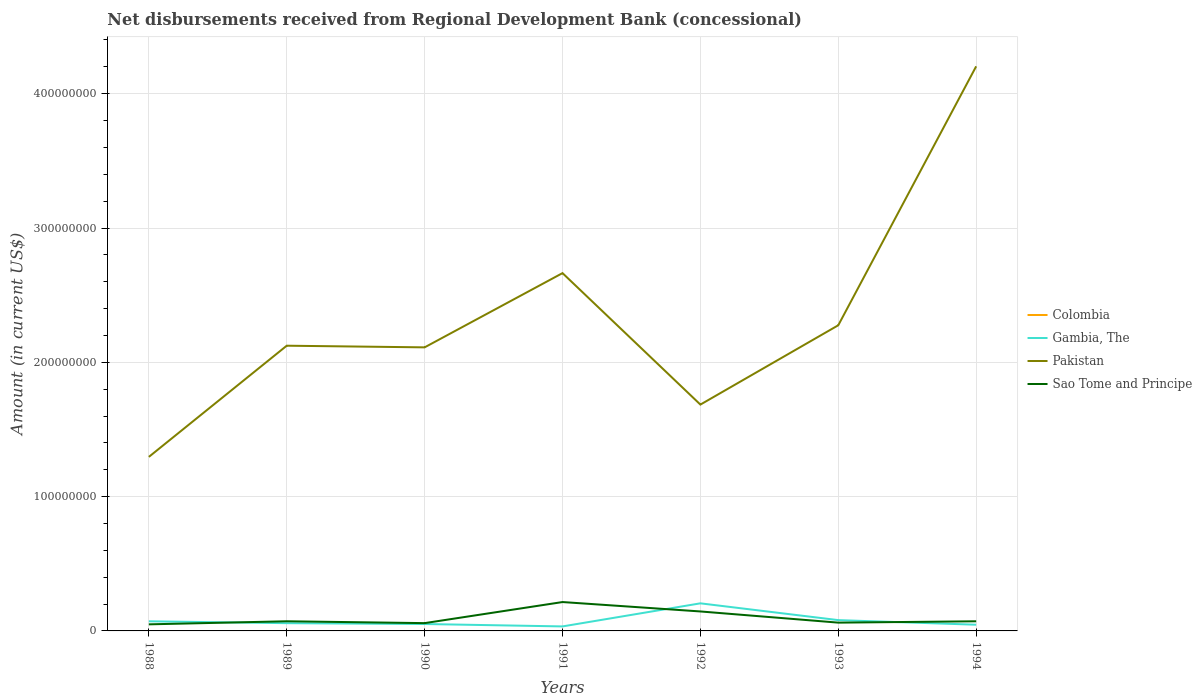How many different coloured lines are there?
Ensure brevity in your answer.  3. Across all years, what is the maximum amount of disbursements received from Regional Development Bank in Pakistan?
Provide a short and direct response. 1.30e+08. What is the total amount of disbursements received from Regional Development Bank in Sao Tome and Principe in the graph?
Keep it short and to the point. 8.32e+06. What is the difference between the highest and the second highest amount of disbursements received from Regional Development Bank in Gambia, The?
Provide a short and direct response. 1.72e+07. Does the graph contain any zero values?
Provide a succinct answer. Yes. Does the graph contain grids?
Make the answer very short. Yes. How many legend labels are there?
Provide a short and direct response. 4. What is the title of the graph?
Offer a very short reply. Net disbursements received from Regional Development Bank (concessional). Does "Argentina" appear as one of the legend labels in the graph?
Keep it short and to the point. No. What is the label or title of the Y-axis?
Your response must be concise. Amount (in current US$). What is the Amount (in current US$) in Gambia, The in 1988?
Make the answer very short. 7.16e+06. What is the Amount (in current US$) of Pakistan in 1988?
Keep it short and to the point. 1.30e+08. What is the Amount (in current US$) in Sao Tome and Principe in 1988?
Your response must be concise. 4.90e+06. What is the Amount (in current US$) of Gambia, The in 1989?
Make the answer very short. 5.77e+06. What is the Amount (in current US$) of Pakistan in 1989?
Offer a very short reply. 2.12e+08. What is the Amount (in current US$) of Sao Tome and Principe in 1989?
Ensure brevity in your answer.  7.19e+06. What is the Amount (in current US$) of Gambia, The in 1990?
Ensure brevity in your answer.  5.14e+06. What is the Amount (in current US$) in Pakistan in 1990?
Provide a short and direct response. 2.11e+08. What is the Amount (in current US$) in Sao Tome and Principe in 1990?
Offer a very short reply. 5.80e+06. What is the Amount (in current US$) of Colombia in 1991?
Give a very brief answer. 0. What is the Amount (in current US$) of Gambia, The in 1991?
Provide a short and direct response. 3.35e+06. What is the Amount (in current US$) in Pakistan in 1991?
Keep it short and to the point. 2.66e+08. What is the Amount (in current US$) of Sao Tome and Principe in 1991?
Give a very brief answer. 2.15e+07. What is the Amount (in current US$) of Colombia in 1992?
Your answer should be very brief. 0. What is the Amount (in current US$) of Gambia, The in 1992?
Provide a succinct answer. 2.05e+07. What is the Amount (in current US$) in Pakistan in 1992?
Provide a succinct answer. 1.69e+08. What is the Amount (in current US$) in Sao Tome and Principe in 1992?
Ensure brevity in your answer.  1.45e+07. What is the Amount (in current US$) in Colombia in 1993?
Make the answer very short. 0. What is the Amount (in current US$) in Gambia, The in 1993?
Your answer should be compact. 8.04e+06. What is the Amount (in current US$) in Pakistan in 1993?
Give a very brief answer. 2.28e+08. What is the Amount (in current US$) in Sao Tome and Principe in 1993?
Keep it short and to the point. 6.17e+06. What is the Amount (in current US$) in Colombia in 1994?
Give a very brief answer. 0. What is the Amount (in current US$) of Gambia, The in 1994?
Offer a terse response. 4.61e+06. What is the Amount (in current US$) in Pakistan in 1994?
Offer a terse response. 4.20e+08. What is the Amount (in current US$) in Sao Tome and Principe in 1994?
Give a very brief answer. 7.17e+06. Across all years, what is the maximum Amount (in current US$) of Gambia, The?
Your answer should be compact. 2.05e+07. Across all years, what is the maximum Amount (in current US$) in Pakistan?
Your answer should be very brief. 4.20e+08. Across all years, what is the maximum Amount (in current US$) of Sao Tome and Principe?
Make the answer very short. 2.15e+07. Across all years, what is the minimum Amount (in current US$) in Gambia, The?
Offer a terse response. 3.35e+06. Across all years, what is the minimum Amount (in current US$) in Pakistan?
Your answer should be very brief. 1.30e+08. Across all years, what is the minimum Amount (in current US$) in Sao Tome and Principe?
Offer a terse response. 4.90e+06. What is the total Amount (in current US$) of Colombia in the graph?
Keep it short and to the point. 0. What is the total Amount (in current US$) in Gambia, The in the graph?
Your answer should be very brief. 5.46e+07. What is the total Amount (in current US$) of Pakistan in the graph?
Your answer should be compact. 1.64e+09. What is the total Amount (in current US$) in Sao Tome and Principe in the graph?
Give a very brief answer. 6.72e+07. What is the difference between the Amount (in current US$) in Gambia, The in 1988 and that in 1989?
Ensure brevity in your answer.  1.40e+06. What is the difference between the Amount (in current US$) in Pakistan in 1988 and that in 1989?
Keep it short and to the point. -8.28e+07. What is the difference between the Amount (in current US$) of Sao Tome and Principe in 1988 and that in 1989?
Provide a short and direct response. -2.30e+06. What is the difference between the Amount (in current US$) of Gambia, The in 1988 and that in 1990?
Keep it short and to the point. 2.02e+06. What is the difference between the Amount (in current US$) in Pakistan in 1988 and that in 1990?
Ensure brevity in your answer.  -8.16e+07. What is the difference between the Amount (in current US$) in Sao Tome and Principe in 1988 and that in 1990?
Give a very brief answer. -9.10e+05. What is the difference between the Amount (in current US$) in Gambia, The in 1988 and that in 1991?
Offer a very short reply. 3.82e+06. What is the difference between the Amount (in current US$) of Pakistan in 1988 and that in 1991?
Provide a short and direct response. -1.37e+08. What is the difference between the Amount (in current US$) of Sao Tome and Principe in 1988 and that in 1991?
Your response must be concise. -1.66e+07. What is the difference between the Amount (in current US$) of Gambia, The in 1988 and that in 1992?
Provide a short and direct response. -1.34e+07. What is the difference between the Amount (in current US$) in Pakistan in 1988 and that in 1992?
Provide a short and direct response. -3.89e+07. What is the difference between the Amount (in current US$) of Sao Tome and Principe in 1988 and that in 1992?
Offer a very short reply. -9.60e+06. What is the difference between the Amount (in current US$) in Gambia, The in 1988 and that in 1993?
Make the answer very short. -8.79e+05. What is the difference between the Amount (in current US$) of Pakistan in 1988 and that in 1993?
Offer a terse response. -9.80e+07. What is the difference between the Amount (in current US$) in Sao Tome and Principe in 1988 and that in 1993?
Offer a very short reply. -1.28e+06. What is the difference between the Amount (in current US$) in Gambia, The in 1988 and that in 1994?
Provide a short and direct response. 2.55e+06. What is the difference between the Amount (in current US$) of Pakistan in 1988 and that in 1994?
Offer a terse response. -2.91e+08. What is the difference between the Amount (in current US$) of Sao Tome and Principe in 1988 and that in 1994?
Keep it short and to the point. -2.28e+06. What is the difference between the Amount (in current US$) of Gambia, The in 1989 and that in 1990?
Provide a short and direct response. 6.28e+05. What is the difference between the Amount (in current US$) in Pakistan in 1989 and that in 1990?
Provide a succinct answer. 1.24e+06. What is the difference between the Amount (in current US$) in Sao Tome and Principe in 1989 and that in 1990?
Provide a short and direct response. 1.39e+06. What is the difference between the Amount (in current US$) in Gambia, The in 1989 and that in 1991?
Give a very brief answer. 2.42e+06. What is the difference between the Amount (in current US$) of Pakistan in 1989 and that in 1991?
Your answer should be compact. -5.40e+07. What is the difference between the Amount (in current US$) of Sao Tome and Principe in 1989 and that in 1991?
Ensure brevity in your answer.  -1.43e+07. What is the difference between the Amount (in current US$) of Gambia, The in 1989 and that in 1992?
Your answer should be very brief. -1.48e+07. What is the difference between the Amount (in current US$) in Pakistan in 1989 and that in 1992?
Your answer should be compact. 4.38e+07. What is the difference between the Amount (in current US$) of Sao Tome and Principe in 1989 and that in 1992?
Provide a short and direct response. -7.30e+06. What is the difference between the Amount (in current US$) of Gambia, The in 1989 and that in 1993?
Make the answer very short. -2.27e+06. What is the difference between the Amount (in current US$) of Pakistan in 1989 and that in 1993?
Offer a terse response. -1.52e+07. What is the difference between the Amount (in current US$) of Sao Tome and Principe in 1989 and that in 1993?
Keep it short and to the point. 1.02e+06. What is the difference between the Amount (in current US$) of Gambia, The in 1989 and that in 1994?
Provide a short and direct response. 1.15e+06. What is the difference between the Amount (in current US$) in Pakistan in 1989 and that in 1994?
Offer a terse response. -2.08e+08. What is the difference between the Amount (in current US$) of Sao Tome and Principe in 1989 and that in 1994?
Keep it short and to the point. 1.70e+04. What is the difference between the Amount (in current US$) in Gambia, The in 1990 and that in 1991?
Provide a succinct answer. 1.79e+06. What is the difference between the Amount (in current US$) in Pakistan in 1990 and that in 1991?
Offer a very short reply. -5.53e+07. What is the difference between the Amount (in current US$) of Sao Tome and Principe in 1990 and that in 1991?
Keep it short and to the point. -1.57e+07. What is the difference between the Amount (in current US$) of Gambia, The in 1990 and that in 1992?
Your answer should be very brief. -1.54e+07. What is the difference between the Amount (in current US$) of Pakistan in 1990 and that in 1992?
Your answer should be compact. 4.26e+07. What is the difference between the Amount (in current US$) in Sao Tome and Principe in 1990 and that in 1992?
Your answer should be compact. -8.69e+06. What is the difference between the Amount (in current US$) of Gambia, The in 1990 and that in 1993?
Keep it short and to the point. -2.90e+06. What is the difference between the Amount (in current US$) of Pakistan in 1990 and that in 1993?
Make the answer very short. -1.65e+07. What is the difference between the Amount (in current US$) of Sao Tome and Principe in 1990 and that in 1993?
Provide a short and direct response. -3.66e+05. What is the difference between the Amount (in current US$) of Gambia, The in 1990 and that in 1994?
Provide a succinct answer. 5.26e+05. What is the difference between the Amount (in current US$) in Pakistan in 1990 and that in 1994?
Your response must be concise. -2.09e+08. What is the difference between the Amount (in current US$) in Sao Tome and Principe in 1990 and that in 1994?
Ensure brevity in your answer.  -1.37e+06. What is the difference between the Amount (in current US$) in Gambia, The in 1991 and that in 1992?
Offer a very short reply. -1.72e+07. What is the difference between the Amount (in current US$) of Pakistan in 1991 and that in 1992?
Your answer should be very brief. 9.79e+07. What is the difference between the Amount (in current US$) of Sao Tome and Principe in 1991 and that in 1992?
Your answer should be very brief. 7.00e+06. What is the difference between the Amount (in current US$) of Gambia, The in 1991 and that in 1993?
Ensure brevity in your answer.  -4.69e+06. What is the difference between the Amount (in current US$) in Pakistan in 1991 and that in 1993?
Offer a very short reply. 3.88e+07. What is the difference between the Amount (in current US$) in Sao Tome and Principe in 1991 and that in 1993?
Keep it short and to the point. 1.53e+07. What is the difference between the Amount (in current US$) in Gambia, The in 1991 and that in 1994?
Offer a terse response. -1.27e+06. What is the difference between the Amount (in current US$) of Pakistan in 1991 and that in 1994?
Provide a short and direct response. -1.54e+08. What is the difference between the Amount (in current US$) in Sao Tome and Principe in 1991 and that in 1994?
Provide a short and direct response. 1.43e+07. What is the difference between the Amount (in current US$) in Gambia, The in 1992 and that in 1993?
Your answer should be very brief. 1.25e+07. What is the difference between the Amount (in current US$) of Pakistan in 1992 and that in 1993?
Offer a terse response. -5.91e+07. What is the difference between the Amount (in current US$) in Sao Tome and Principe in 1992 and that in 1993?
Your answer should be very brief. 8.32e+06. What is the difference between the Amount (in current US$) of Gambia, The in 1992 and that in 1994?
Your answer should be compact. 1.59e+07. What is the difference between the Amount (in current US$) of Pakistan in 1992 and that in 1994?
Your answer should be very brief. -2.52e+08. What is the difference between the Amount (in current US$) of Sao Tome and Principe in 1992 and that in 1994?
Offer a terse response. 7.32e+06. What is the difference between the Amount (in current US$) of Gambia, The in 1993 and that in 1994?
Offer a terse response. 3.43e+06. What is the difference between the Amount (in current US$) of Pakistan in 1993 and that in 1994?
Your answer should be very brief. -1.93e+08. What is the difference between the Amount (in current US$) in Sao Tome and Principe in 1993 and that in 1994?
Make the answer very short. -1.00e+06. What is the difference between the Amount (in current US$) of Gambia, The in 1988 and the Amount (in current US$) of Pakistan in 1989?
Your response must be concise. -2.05e+08. What is the difference between the Amount (in current US$) of Gambia, The in 1988 and the Amount (in current US$) of Sao Tome and Principe in 1989?
Provide a succinct answer. -2.80e+04. What is the difference between the Amount (in current US$) of Pakistan in 1988 and the Amount (in current US$) of Sao Tome and Principe in 1989?
Keep it short and to the point. 1.22e+08. What is the difference between the Amount (in current US$) of Gambia, The in 1988 and the Amount (in current US$) of Pakistan in 1990?
Offer a terse response. -2.04e+08. What is the difference between the Amount (in current US$) in Gambia, The in 1988 and the Amount (in current US$) in Sao Tome and Principe in 1990?
Your answer should be very brief. 1.36e+06. What is the difference between the Amount (in current US$) in Pakistan in 1988 and the Amount (in current US$) in Sao Tome and Principe in 1990?
Your answer should be very brief. 1.24e+08. What is the difference between the Amount (in current US$) of Gambia, The in 1988 and the Amount (in current US$) of Pakistan in 1991?
Ensure brevity in your answer.  -2.59e+08. What is the difference between the Amount (in current US$) in Gambia, The in 1988 and the Amount (in current US$) in Sao Tome and Principe in 1991?
Ensure brevity in your answer.  -1.43e+07. What is the difference between the Amount (in current US$) in Pakistan in 1988 and the Amount (in current US$) in Sao Tome and Principe in 1991?
Ensure brevity in your answer.  1.08e+08. What is the difference between the Amount (in current US$) of Gambia, The in 1988 and the Amount (in current US$) of Pakistan in 1992?
Your response must be concise. -1.61e+08. What is the difference between the Amount (in current US$) in Gambia, The in 1988 and the Amount (in current US$) in Sao Tome and Principe in 1992?
Ensure brevity in your answer.  -7.33e+06. What is the difference between the Amount (in current US$) in Pakistan in 1988 and the Amount (in current US$) in Sao Tome and Principe in 1992?
Your answer should be very brief. 1.15e+08. What is the difference between the Amount (in current US$) in Gambia, The in 1988 and the Amount (in current US$) in Pakistan in 1993?
Provide a short and direct response. -2.20e+08. What is the difference between the Amount (in current US$) of Gambia, The in 1988 and the Amount (in current US$) of Sao Tome and Principe in 1993?
Your answer should be very brief. 9.92e+05. What is the difference between the Amount (in current US$) of Pakistan in 1988 and the Amount (in current US$) of Sao Tome and Principe in 1993?
Your answer should be compact. 1.23e+08. What is the difference between the Amount (in current US$) in Gambia, The in 1988 and the Amount (in current US$) in Pakistan in 1994?
Your answer should be very brief. -4.13e+08. What is the difference between the Amount (in current US$) in Gambia, The in 1988 and the Amount (in current US$) in Sao Tome and Principe in 1994?
Your response must be concise. -1.10e+04. What is the difference between the Amount (in current US$) in Pakistan in 1988 and the Amount (in current US$) in Sao Tome and Principe in 1994?
Your response must be concise. 1.22e+08. What is the difference between the Amount (in current US$) in Gambia, The in 1989 and the Amount (in current US$) in Pakistan in 1990?
Provide a short and direct response. -2.05e+08. What is the difference between the Amount (in current US$) in Gambia, The in 1989 and the Amount (in current US$) in Sao Tome and Principe in 1990?
Your answer should be very brief. -3.70e+04. What is the difference between the Amount (in current US$) in Pakistan in 1989 and the Amount (in current US$) in Sao Tome and Principe in 1990?
Give a very brief answer. 2.07e+08. What is the difference between the Amount (in current US$) in Gambia, The in 1989 and the Amount (in current US$) in Pakistan in 1991?
Your answer should be compact. -2.61e+08. What is the difference between the Amount (in current US$) in Gambia, The in 1989 and the Amount (in current US$) in Sao Tome and Principe in 1991?
Your answer should be compact. -1.57e+07. What is the difference between the Amount (in current US$) of Pakistan in 1989 and the Amount (in current US$) of Sao Tome and Principe in 1991?
Your answer should be compact. 1.91e+08. What is the difference between the Amount (in current US$) of Gambia, The in 1989 and the Amount (in current US$) of Pakistan in 1992?
Provide a succinct answer. -1.63e+08. What is the difference between the Amount (in current US$) of Gambia, The in 1989 and the Amount (in current US$) of Sao Tome and Principe in 1992?
Your answer should be very brief. -8.72e+06. What is the difference between the Amount (in current US$) of Pakistan in 1989 and the Amount (in current US$) of Sao Tome and Principe in 1992?
Ensure brevity in your answer.  1.98e+08. What is the difference between the Amount (in current US$) of Gambia, The in 1989 and the Amount (in current US$) of Pakistan in 1993?
Your answer should be compact. -2.22e+08. What is the difference between the Amount (in current US$) in Gambia, The in 1989 and the Amount (in current US$) in Sao Tome and Principe in 1993?
Keep it short and to the point. -4.03e+05. What is the difference between the Amount (in current US$) of Pakistan in 1989 and the Amount (in current US$) of Sao Tome and Principe in 1993?
Provide a short and direct response. 2.06e+08. What is the difference between the Amount (in current US$) of Gambia, The in 1989 and the Amount (in current US$) of Pakistan in 1994?
Make the answer very short. -4.15e+08. What is the difference between the Amount (in current US$) of Gambia, The in 1989 and the Amount (in current US$) of Sao Tome and Principe in 1994?
Give a very brief answer. -1.41e+06. What is the difference between the Amount (in current US$) in Pakistan in 1989 and the Amount (in current US$) in Sao Tome and Principe in 1994?
Your answer should be compact. 2.05e+08. What is the difference between the Amount (in current US$) in Gambia, The in 1990 and the Amount (in current US$) in Pakistan in 1991?
Offer a very short reply. -2.61e+08. What is the difference between the Amount (in current US$) of Gambia, The in 1990 and the Amount (in current US$) of Sao Tome and Principe in 1991?
Your response must be concise. -1.64e+07. What is the difference between the Amount (in current US$) in Pakistan in 1990 and the Amount (in current US$) in Sao Tome and Principe in 1991?
Your response must be concise. 1.90e+08. What is the difference between the Amount (in current US$) in Gambia, The in 1990 and the Amount (in current US$) in Pakistan in 1992?
Make the answer very short. -1.63e+08. What is the difference between the Amount (in current US$) in Gambia, The in 1990 and the Amount (in current US$) in Sao Tome and Principe in 1992?
Provide a succinct answer. -9.35e+06. What is the difference between the Amount (in current US$) in Pakistan in 1990 and the Amount (in current US$) in Sao Tome and Principe in 1992?
Give a very brief answer. 1.97e+08. What is the difference between the Amount (in current US$) in Gambia, The in 1990 and the Amount (in current US$) in Pakistan in 1993?
Offer a very short reply. -2.22e+08. What is the difference between the Amount (in current US$) in Gambia, The in 1990 and the Amount (in current US$) in Sao Tome and Principe in 1993?
Provide a short and direct response. -1.03e+06. What is the difference between the Amount (in current US$) of Pakistan in 1990 and the Amount (in current US$) of Sao Tome and Principe in 1993?
Keep it short and to the point. 2.05e+08. What is the difference between the Amount (in current US$) in Gambia, The in 1990 and the Amount (in current US$) in Pakistan in 1994?
Provide a short and direct response. -4.15e+08. What is the difference between the Amount (in current US$) of Gambia, The in 1990 and the Amount (in current US$) of Sao Tome and Principe in 1994?
Keep it short and to the point. -2.03e+06. What is the difference between the Amount (in current US$) of Pakistan in 1990 and the Amount (in current US$) of Sao Tome and Principe in 1994?
Provide a succinct answer. 2.04e+08. What is the difference between the Amount (in current US$) of Gambia, The in 1991 and the Amount (in current US$) of Pakistan in 1992?
Provide a short and direct response. -1.65e+08. What is the difference between the Amount (in current US$) in Gambia, The in 1991 and the Amount (in current US$) in Sao Tome and Principe in 1992?
Keep it short and to the point. -1.11e+07. What is the difference between the Amount (in current US$) of Pakistan in 1991 and the Amount (in current US$) of Sao Tome and Principe in 1992?
Your response must be concise. 2.52e+08. What is the difference between the Amount (in current US$) in Gambia, The in 1991 and the Amount (in current US$) in Pakistan in 1993?
Ensure brevity in your answer.  -2.24e+08. What is the difference between the Amount (in current US$) in Gambia, The in 1991 and the Amount (in current US$) in Sao Tome and Principe in 1993?
Keep it short and to the point. -2.82e+06. What is the difference between the Amount (in current US$) in Pakistan in 1991 and the Amount (in current US$) in Sao Tome and Principe in 1993?
Keep it short and to the point. 2.60e+08. What is the difference between the Amount (in current US$) of Gambia, The in 1991 and the Amount (in current US$) of Pakistan in 1994?
Offer a terse response. -4.17e+08. What is the difference between the Amount (in current US$) in Gambia, The in 1991 and the Amount (in current US$) in Sao Tome and Principe in 1994?
Your answer should be compact. -3.83e+06. What is the difference between the Amount (in current US$) of Pakistan in 1991 and the Amount (in current US$) of Sao Tome and Principe in 1994?
Keep it short and to the point. 2.59e+08. What is the difference between the Amount (in current US$) of Gambia, The in 1992 and the Amount (in current US$) of Pakistan in 1993?
Ensure brevity in your answer.  -2.07e+08. What is the difference between the Amount (in current US$) in Gambia, The in 1992 and the Amount (in current US$) in Sao Tome and Principe in 1993?
Offer a very short reply. 1.44e+07. What is the difference between the Amount (in current US$) of Pakistan in 1992 and the Amount (in current US$) of Sao Tome and Principe in 1993?
Give a very brief answer. 1.62e+08. What is the difference between the Amount (in current US$) in Gambia, The in 1992 and the Amount (in current US$) in Pakistan in 1994?
Your answer should be very brief. -4.00e+08. What is the difference between the Amount (in current US$) in Gambia, The in 1992 and the Amount (in current US$) in Sao Tome and Principe in 1994?
Offer a terse response. 1.34e+07. What is the difference between the Amount (in current US$) of Pakistan in 1992 and the Amount (in current US$) of Sao Tome and Principe in 1994?
Provide a short and direct response. 1.61e+08. What is the difference between the Amount (in current US$) of Gambia, The in 1993 and the Amount (in current US$) of Pakistan in 1994?
Provide a succinct answer. -4.12e+08. What is the difference between the Amount (in current US$) in Gambia, The in 1993 and the Amount (in current US$) in Sao Tome and Principe in 1994?
Your answer should be very brief. 8.68e+05. What is the difference between the Amount (in current US$) of Pakistan in 1993 and the Amount (in current US$) of Sao Tome and Principe in 1994?
Make the answer very short. 2.20e+08. What is the average Amount (in current US$) in Gambia, The per year?
Offer a very short reply. 7.80e+06. What is the average Amount (in current US$) in Pakistan per year?
Give a very brief answer. 2.34e+08. What is the average Amount (in current US$) of Sao Tome and Principe per year?
Offer a very short reply. 9.60e+06. In the year 1988, what is the difference between the Amount (in current US$) in Gambia, The and Amount (in current US$) in Pakistan?
Keep it short and to the point. -1.22e+08. In the year 1988, what is the difference between the Amount (in current US$) in Gambia, The and Amount (in current US$) in Sao Tome and Principe?
Make the answer very short. 2.27e+06. In the year 1988, what is the difference between the Amount (in current US$) of Pakistan and Amount (in current US$) of Sao Tome and Principe?
Your answer should be compact. 1.25e+08. In the year 1989, what is the difference between the Amount (in current US$) of Gambia, The and Amount (in current US$) of Pakistan?
Your response must be concise. -2.07e+08. In the year 1989, what is the difference between the Amount (in current US$) of Gambia, The and Amount (in current US$) of Sao Tome and Principe?
Provide a succinct answer. -1.42e+06. In the year 1989, what is the difference between the Amount (in current US$) of Pakistan and Amount (in current US$) of Sao Tome and Principe?
Keep it short and to the point. 2.05e+08. In the year 1990, what is the difference between the Amount (in current US$) of Gambia, The and Amount (in current US$) of Pakistan?
Keep it short and to the point. -2.06e+08. In the year 1990, what is the difference between the Amount (in current US$) of Gambia, The and Amount (in current US$) of Sao Tome and Principe?
Provide a succinct answer. -6.65e+05. In the year 1990, what is the difference between the Amount (in current US$) in Pakistan and Amount (in current US$) in Sao Tome and Principe?
Ensure brevity in your answer.  2.05e+08. In the year 1991, what is the difference between the Amount (in current US$) of Gambia, The and Amount (in current US$) of Pakistan?
Make the answer very short. -2.63e+08. In the year 1991, what is the difference between the Amount (in current US$) in Gambia, The and Amount (in current US$) in Sao Tome and Principe?
Keep it short and to the point. -1.81e+07. In the year 1991, what is the difference between the Amount (in current US$) in Pakistan and Amount (in current US$) in Sao Tome and Principe?
Offer a very short reply. 2.45e+08. In the year 1992, what is the difference between the Amount (in current US$) of Gambia, The and Amount (in current US$) of Pakistan?
Give a very brief answer. -1.48e+08. In the year 1992, what is the difference between the Amount (in current US$) in Gambia, The and Amount (in current US$) in Sao Tome and Principe?
Your response must be concise. 6.05e+06. In the year 1992, what is the difference between the Amount (in current US$) of Pakistan and Amount (in current US$) of Sao Tome and Principe?
Your response must be concise. 1.54e+08. In the year 1993, what is the difference between the Amount (in current US$) of Gambia, The and Amount (in current US$) of Pakistan?
Your answer should be very brief. -2.20e+08. In the year 1993, what is the difference between the Amount (in current US$) of Gambia, The and Amount (in current US$) of Sao Tome and Principe?
Your answer should be very brief. 1.87e+06. In the year 1993, what is the difference between the Amount (in current US$) in Pakistan and Amount (in current US$) in Sao Tome and Principe?
Offer a very short reply. 2.21e+08. In the year 1994, what is the difference between the Amount (in current US$) in Gambia, The and Amount (in current US$) in Pakistan?
Offer a terse response. -4.16e+08. In the year 1994, what is the difference between the Amount (in current US$) of Gambia, The and Amount (in current US$) of Sao Tome and Principe?
Make the answer very short. -2.56e+06. In the year 1994, what is the difference between the Amount (in current US$) of Pakistan and Amount (in current US$) of Sao Tome and Principe?
Provide a short and direct response. 4.13e+08. What is the ratio of the Amount (in current US$) in Gambia, The in 1988 to that in 1989?
Your response must be concise. 1.24. What is the ratio of the Amount (in current US$) in Pakistan in 1988 to that in 1989?
Keep it short and to the point. 0.61. What is the ratio of the Amount (in current US$) of Sao Tome and Principe in 1988 to that in 1989?
Keep it short and to the point. 0.68. What is the ratio of the Amount (in current US$) of Gambia, The in 1988 to that in 1990?
Provide a succinct answer. 1.39. What is the ratio of the Amount (in current US$) of Pakistan in 1988 to that in 1990?
Your answer should be compact. 0.61. What is the ratio of the Amount (in current US$) of Sao Tome and Principe in 1988 to that in 1990?
Ensure brevity in your answer.  0.84. What is the ratio of the Amount (in current US$) of Gambia, The in 1988 to that in 1991?
Provide a short and direct response. 2.14. What is the ratio of the Amount (in current US$) of Pakistan in 1988 to that in 1991?
Keep it short and to the point. 0.49. What is the ratio of the Amount (in current US$) in Sao Tome and Principe in 1988 to that in 1991?
Offer a very short reply. 0.23. What is the ratio of the Amount (in current US$) of Gambia, The in 1988 to that in 1992?
Keep it short and to the point. 0.35. What is the ratio of the Amount (in current US$) of Pakistan in 1988 to that in 1992?
Your response must be concise. 0.77. What is the ratio of the Amount (in current US$) of Sao Tome and Principe in 1988 to that in 1992?
Offer a terse response. 0.34. What is the ratio of the Amount (in current US$) in Gambia, The in 1988 to that in 1993?
Offer a very short reply. 0.89. What is the ratio of the Amount (in current US$) in Pakistan in 1988 to that in 1993?
Your answer should be compact. 0.57. What is the ratio of the Amount (in current US$) of Sao Tome and Principe in 1988 to that in 1993?
Your answer should be compact. 0.79. What is the ratio of the Amount (in current US$) in Gambia, The in 1988 to that in 1994?
Offer a terse response. 1.55. What is the ratio of the Amount (in current US$) of Pakistan in 1988 to that in 1994?
Your answer should be very brief. 0.31. What is the ratio of the Amount (in current US$) of Sao Tome and Principe in 1988 to that in 1994?
Your answer should be very brief. 0.68. What is the ratio of the Amount (in current US$) of Gambia, The in 1989 to that in 1990?
Provide a short and direct response. 1.12. What is the ratio of the Amount (in current US$) in Pakistan in 1989 to that in 1990?
Your answer should be compact. 1.01. What is the ratio of the Amount (in current US$) in Sao Tome and Principe in 1989 to that in 1990?
Ensure brevity in your answer.  1.24. What is the ratio of the Amount (in current US$) in Gambia, The in 1989 to that in 1991?
Provide a short and direct response. 1.72. What is the ratio of the Amount (in current US$) of Pakistan in 1989 to that in 1991?
Give a very brief answer. 0.8. What is the ratio of the Amount (in current US$) of Sao Tome and Principe in 1989 to that in 1991?
Ensure brevity in your answer.  0.33. What is the ratio of the Amount (in current US$) in Gambia, The in 1989 to that in 1992?
Offer a very short reply. 0.28. What is the ratio of the Amount (in current US$) of Pakistan in 1989 to that in 1992?
Offer a terse response. 1.26. What is the ratio of the Amount (in current US$) of Sao Tome and Principe in 1989 to that in 1992?
Give a very brief answer. 0.5. What is the ratio of the Amount (in current US$) in Gambia, The in 1989 to that in 1993?
Make the answer very short. 0.72. What is the ratio of the Amount (in current US$) in Pakistan in 1989 to that in 1993?
Give a very brief answer. 0.93. What is the ratio of the Amount (in current US$) of Sao Tome and Principe in 1989 to that in 1993?
Offer a terse response. 1.17. What is the ratio of the Amount (in current US$) of Gambia, The in 1989 to that in 1994?
Offer a very short reply. 1.25. What is the ratio of the Amount (in current US$) of Pakistan in 1989 to that in 1994?
Provide a short and direct response. 0.51. What is the ratio of the Amount (in current US$) of Gambia, The in 1990 to that in 1991?
Make the answer very short. 1.54. What is the ratio of the Amount (in current US$) of Pakistan in 1990 to that in 1991?
Offer a terse response. 0.79. What is the ratio of the Amount (in current US$) of Sao Tome and Principe in 1990 to that in 1991?
Make the answer very short. 0.27. What is the ratio of the Amount (in current US$) in Gambia, The in 1990 to that in 1992?
Keep it short and to the point. 0.25. What is the ratio of the Amount (in current US$) in Pakistan in 1990 to that in 1992?
Make the answer very short. 1.25. What is the ratio of the Amount (in current US$) in Sao Tome and Principe in 1990 to that in 1992?
Make the answer very short. 0.4. What is the ratio of the Amount (in current US$) in Gambia, The in 1990 to that in 1993?
Provide a succinct answer. 0.64. What is the ratio of the Amount (in current US$) in Pakistan in 1990 to that in 1993?
Keep it short and to the point. 0.93. What is the ratio of the Amount (in current US$) in Sao Tome and Principe in 1990 to that in 1993?
Give a very brief answer. 0.94. What is the ratio of the Amount (in current US$) in Gambia, The in 1990 to that in 1994?
Offer a very short reply. 1.11. What is the ratio of the Amount (in current US$) of Pakistan in 1990 to that in 1994?
Your answer should be very brief. 0.5. What is the ratio of the Amount (in current US$) of Sao Tome and Principe in 1990 to that in 1994?
Give a very brief answer. 0.81. What is the ratio of the Amount (in current US$) of Gambia, The in 1991 to that in 1992?
Give a very brief answer. 0.16. What is the ratio of the Amount (in current US$) in Pakistan in 1991 to that in 1992?
Give a very brief answer. 1.58. What is the ratio of the Amount (in current US$) in Sao Tome and Principe in 1991 to that in 1992?
Provide a succinct answer. 1.48. What is the ratio of the Amount (in current US$) in Gambia, The in 1991 to that in 1993?
Your answer should be very brief. 0.42. What is the ratio of the Amount (in current US$) in Pakistan in 1991 to that in 1993?
Your answer should be compact. 1.17. What is the ratio of the Amount (in current US$) in Sao Tome and Principe in 1991 to that in 1993?
Your answer should be compact. 3.48. What is the ratio of the Amount (in current US$) of Gambia, The in 1991 to that in 1994?
Offer a terse response. 0.73. What is the ratio of the Amount (in current US$) in Pakistan in 1991 to that in 1994?
Make the answer very short. 0.63. What is the ratio of the Amount (in current US$) of Sao Tome and Principe in 1991 to that in 1994?
Your answer should be very brief. 3. What is the ratio of the Amount (in current US$) of Gambia, The in 1992 to that in 1993?
Provide a short and direct response. 2.55. What is the ratio of the Amount (in current US$) in Pakistan in 1992 to that in 1993?
Offer a very short reply. 0.74. What is the ratio of the Amount (in current US$) in Sao Tome and Principe in 1992 to that in 1993?
Make the answer very short. 2.35. What is the ratio of the Amount (in current US$) in Gambia, The in 1992 to that in 1994?
Keep it short and to the point. 4.45. What is the ratio of the Amount (in current US$) in Pakistan in 1992 to that in 1994?
Your answer should be compact. 0.4. What is the ratio of the Amount (in current US$) of Sao Tome and Principe in 1992 to that in 1994?
Make the answer very short. 2.02. What is the ratio of the Amount (in current US$) in Gambia, The in 1993 to that in 1994?
Ensure brevity in your answer.  1.74. What is the ratio of the Amount (in current US$) of Pakistan in 1993 to that in 1994?
Keep it short and to the point. 0.54. What is the ratio of the Amount (in current US$) of Sao Tome and Principe in 1993 to that in 1994?
Offer a terse response. 0.86. What is the difference between the highest and the second highest Amount (in current US$) in Gambia, The?
Give a very brief answer. 1.25e+07. What is the difference between the highest and the second highest Amount (in current US$) of Pakistan?
Keep it short and to the point. 1.54e+08. What is the difference between the highest and the second highest Amount (in current US$) of Sao Tome and Principe?
Keep it short and to the point. 7.00e+06. What is the difference between the highest and the lowest Amount (in current US$) in Gambia, The?
Your answer should be very brief. 1.72e+07. What is the difference between the highest and the lowest Amount (in current US$) of Pakistan?
Your answer should be compact. 2.91e+08. What is the difference between the highest and the lowest Amount (in current US$) in Sao Tome and Principe?
Give a very brief answer. 1.66e+07. 